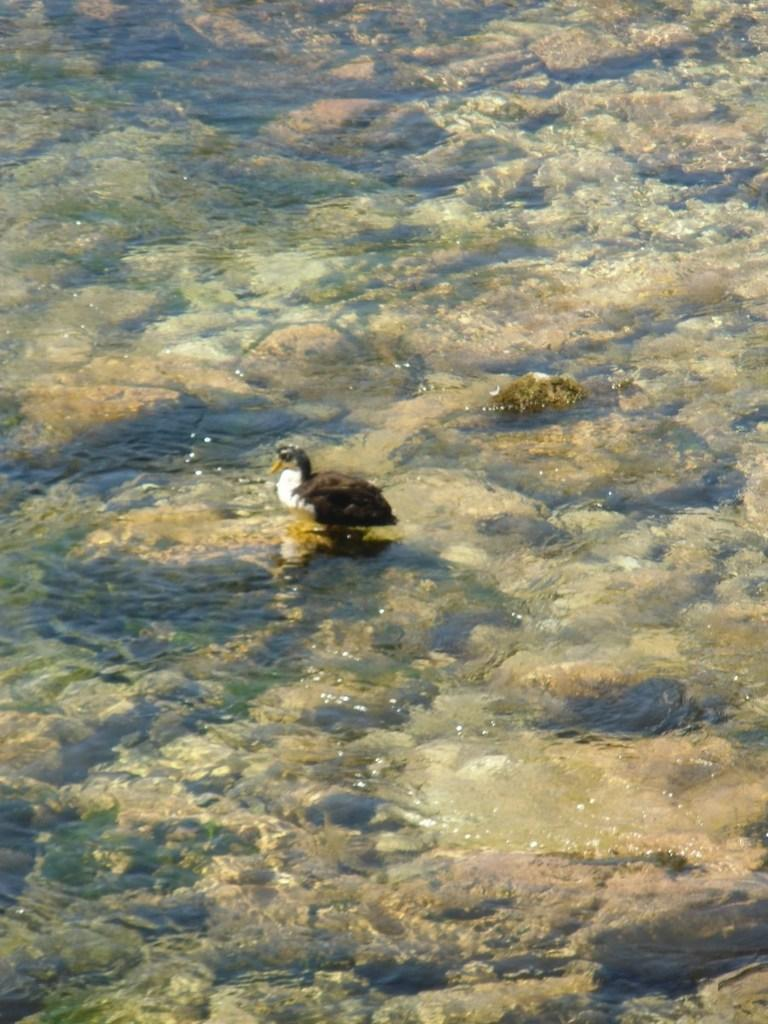What animal is present in the image? There is a duck in the image. Where is the duck located? The duck is on the water. What can be seen under the water in the image? There are stones under the water in the image. What type of needle is the duck using to sew a tablecloth in the image? There is no needle or tablecloth present in the image; it features a duck on the water with stones under the water. 